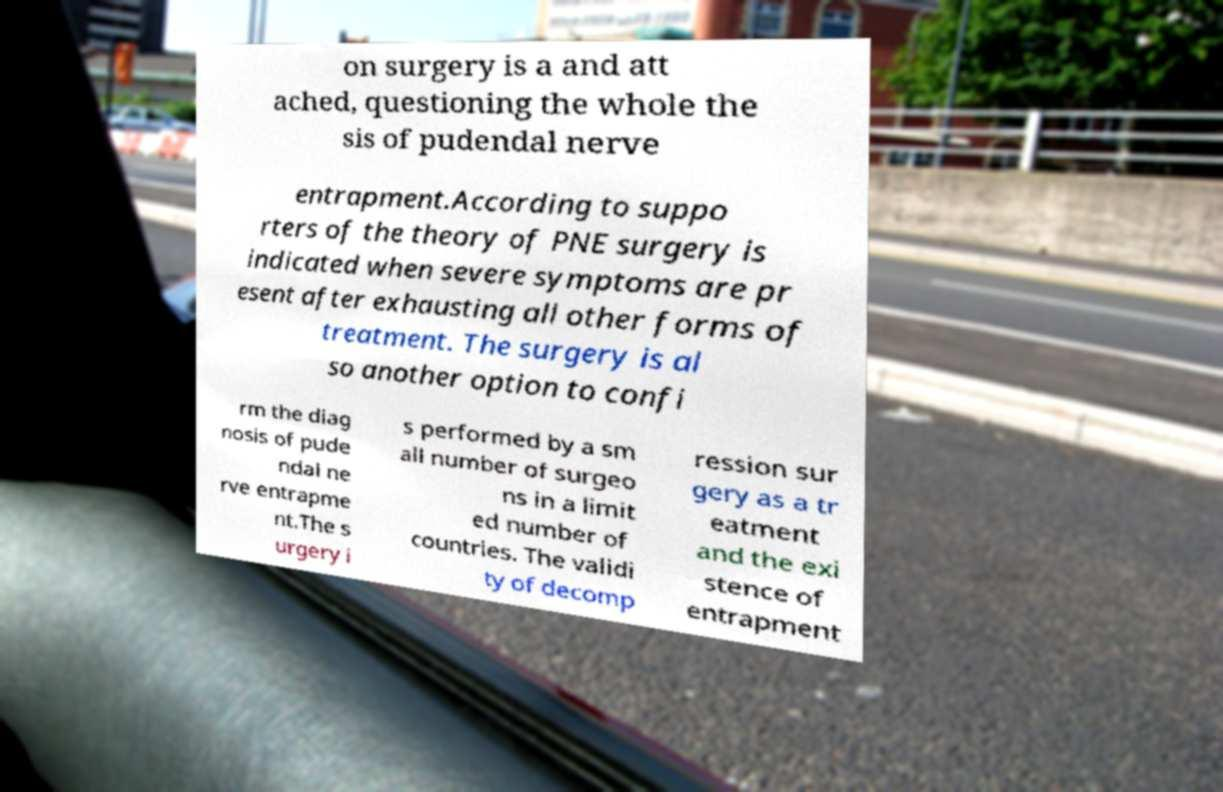There's text embedded in this image that I need extracted. Can you transcribe it verbatim? on surgery is a and att ached, questioning the whole the sis of pudendal nerve entrapment.According to suppo rters of the theory of PNE surgery is indicated when severe symptoms are pr esent after exhausting all other forms of treatment. The surgery is al so another option to confi rm the diag nosis of pude ndal ne rve entrapme nt.The s urgery i s performed by a sm all number of surgeo ns in a limit ed number of countries. The validi ty of decomp ression sur gery as a tr eatment and the exi stence of entrapment 